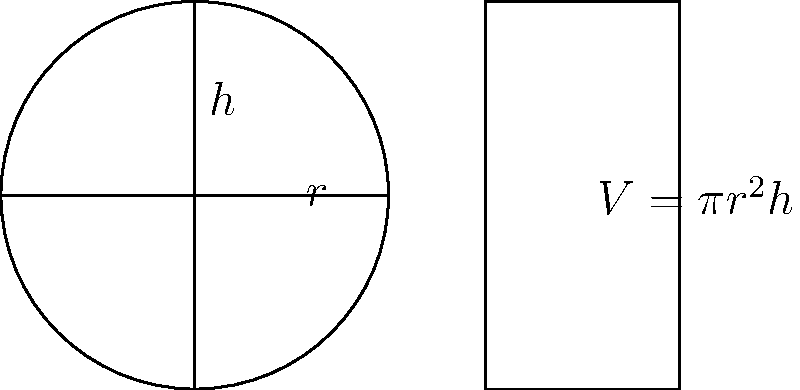Hey, party people! Let's mix it up with some concrete calculations. Imagine you're filling a cylindrical water tank for the club's new foam party. If the tank has a radius of 3 meters and a height of 5 meters, how many cubic meters of concrete would you need to create this tank, assuming the walls are 0.2 meters thick? Round your answer to the nearest whole number, because we don't do partial pours in this joint! Alright, let's break this down like we're crafting the perfect cocktail:

1) First, we need to calculate the volume of the outer cylinder:
   $V_{outer} = \pi r_{outer}^2 h_{outer}$
   $r_{outer} = 3 + 0.2 = 3.2$ m (including wall thickness)
   $h_{outer} = 5 + 0.2 = 5.2$ m (including bottom thickness)
   $V_{outer} = \pi (3.2)^2 (5.2) = 167.55$ m³

2) Now, let's calculate the volume of the inner cylinder (the actual water space):
   $V_{inner} = \pi r_{inner}^2 h_{inner}$
   $r_{inner} = 3$ m
   $h_{inner} = 5$ m
   $V_{inner} = \pi (3)^2 (5) = 141.37$ m³

3) The volume of concrete needed is the difference between these two:
   $V_{concrete} = V_{outer} - V_{inner}$
   $V_{concrete} = 167.55 - 141.37 = 26.18$ m³

4) Rounding to the nearest whole number:
   $V_{concrete} \approx 26$ m³

So, just like we round up that last drink to an even number, we'll round up our concrete to 26 cubic meters.
Answer: 26 m³ 